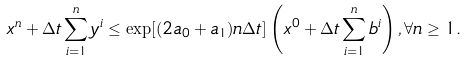<formula> <loc_0><loc_0><loc_500><loc_500>x ^ { n } + \Delta t \sum _ { i = 1 } ^ { n } y ^ { i } \leq \exp [ ( 2 a _ { 0 } + a _ { 1 } ) n \Delta t ] \left ( x ^ { 0 } + \Delta t \sum _ { i = 1 } ^ { n } b ^ { i } \right ) , \forall n \geq 1 .</formula> 